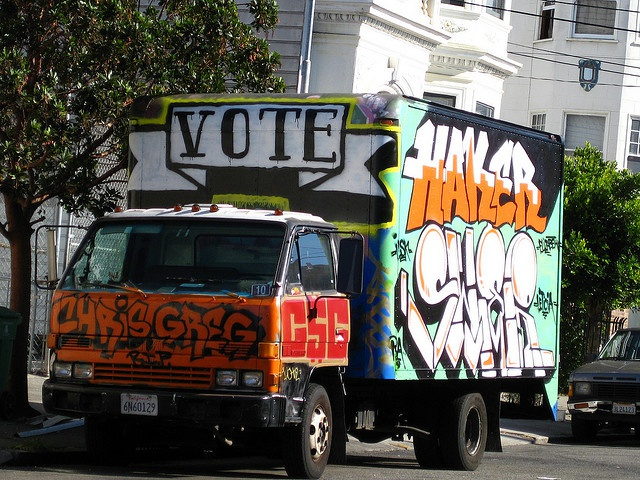Describe the objects in this image and their specific colors. I can see truck in black, white, gray, and darkgray tones and car in black, gray, and darkgray tones in this image. 